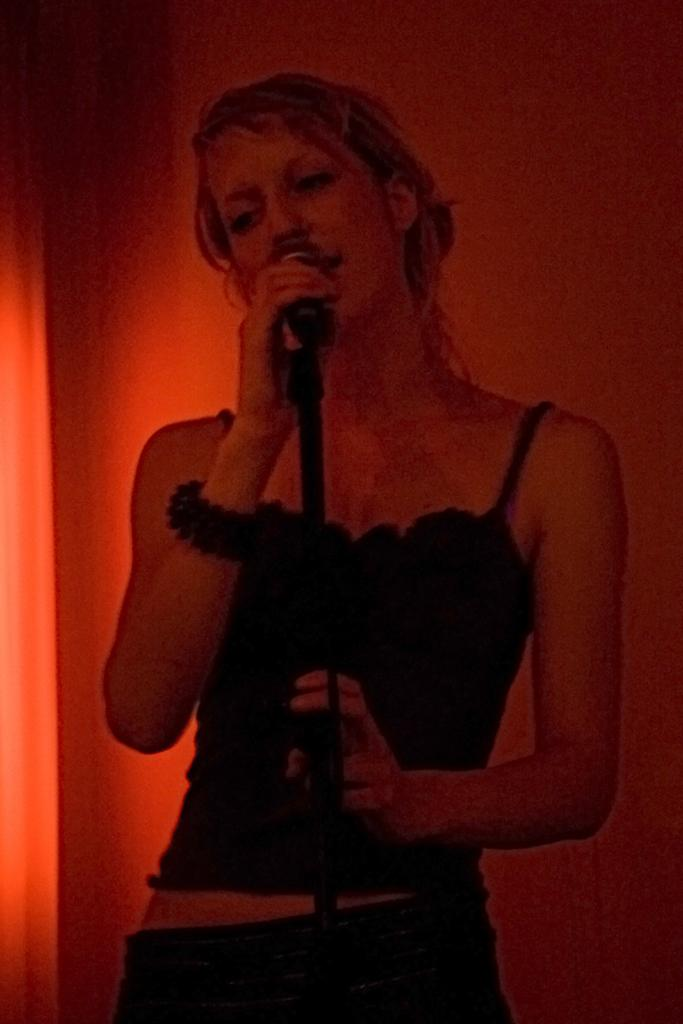Who is the main subject in the image? There is a woman in the image. What is the woman doing in the image? The woman is standing and singing. What object is the woman holding in the image? The woman is holding a microphone. What is the color of the background in the image? The background color is pink. How many pairs of socks can be seen on the woman's feet in the image? There is no information about socks or the woman's feet in the image, so it cannot be determined. What type of apples are being used as a prop in the image? There are no apples present in the image. 